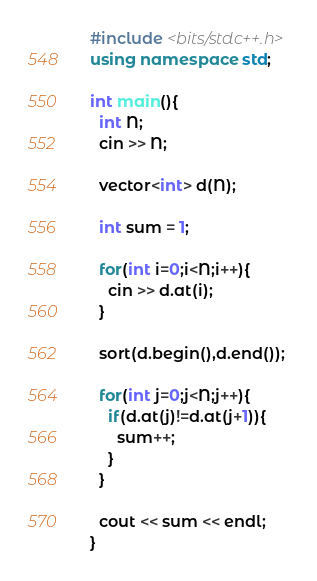<code> <loc_0><loc_0><loc_500><loc_500><_C++_>#include <bits/stdc++.h>
using namespace std;

int main(){
  int N;
  cin >> N;
  
  vector<int> d(N);
  
  int sum = 1;
  
  for(int i=0;i<N;i++){
    cin >> d.at(i);
  }
  
  sort(d.begin(),d.end());
  
  for(int j=0;j<N;j++){
    if(d.at(j)!=d.at(j+1)){
      sum++;
    }
  }

  cout << sum << endl;
}
</code> 